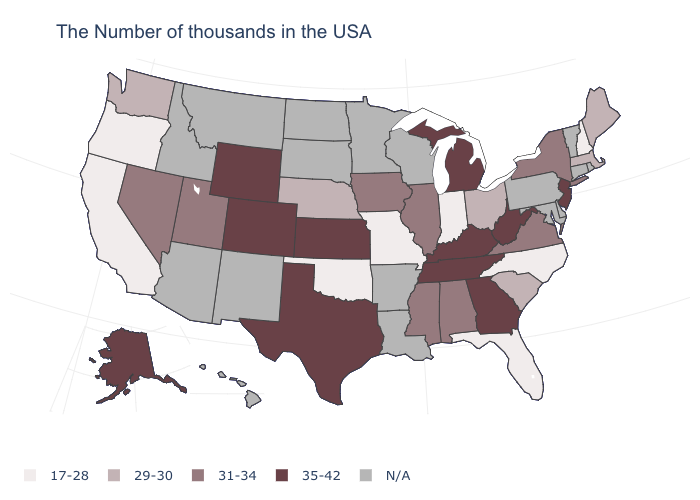What is the value of Maryland?
Write a very short answer. N/A. What is the value of New Hampshire?
Short answer required. 17-28. What is the lowest value in the West?
Quick response, please. 17-28. What is the value of Maine?
Quick response, please. 29-30. What is the value of Wisconsin?
Give a very brief answer. N/A. What is the lowest value in the USA?
Quick response, please. 17-28. Name the states that have a value in the range 17-28?
Give a very brief answer. New Hampshire, North Carolina, Florida, Indiana, Missouri, Oklahoma, California, Oregon. What is the value of Massachusetts?
Be succinct. 29-30. What is the value of New York?
Give a very brief answer. 31-34. Which states hav the highest value in the MidWest?
Give a very brief answer. Michigan, Kansas. What is the value of Pennsylvania?
Concise answer only. N/A. Does New York have the highest value in the Northeast?
Quick response, please. No. Does the map have missing data?
Quick response, please. Yes. 